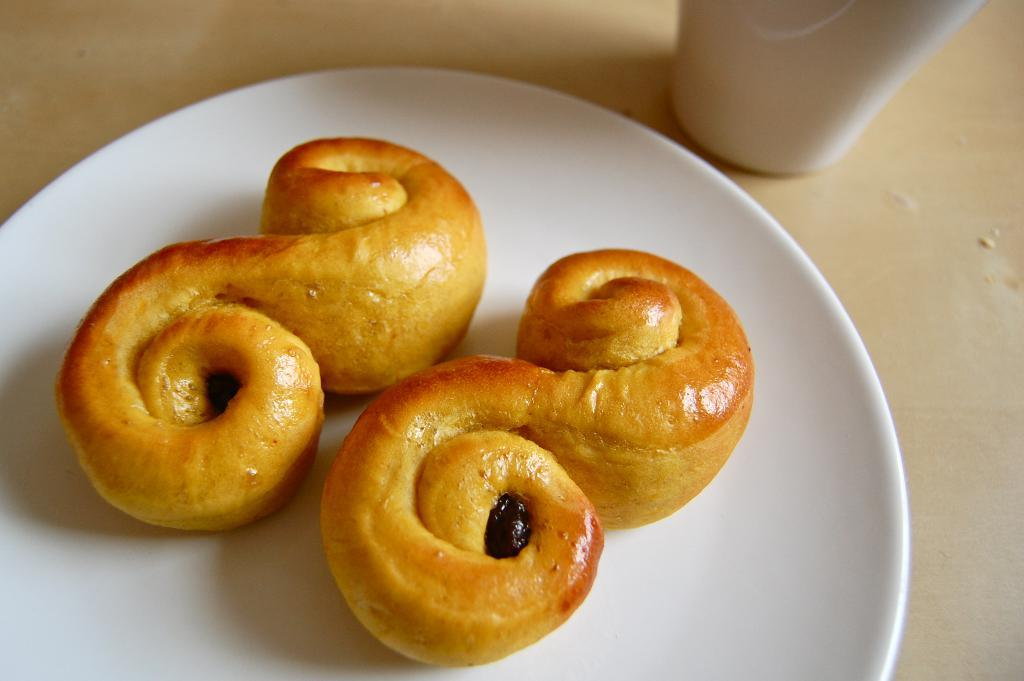What is the main object in the center of the image? There is a plate in the center of the image. What is on the plate? It appears that there are donuts on the plate. What else can be seen in the image besides the plate and donuts? There is a glass visible at the top side of the image. How many friends are sitting around the table in the image? There is no table or friends present in the image; it only shows a plate with donuts and a glass. What type of bomb can be seen in the image? There is no bomb present in the image. 